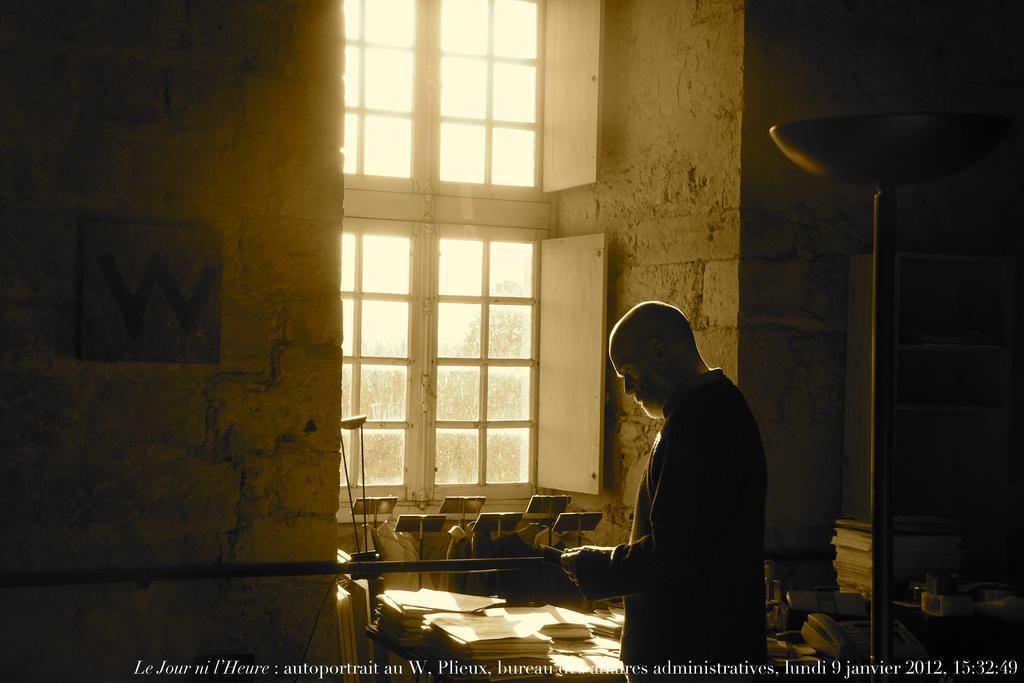Could you give a brief overview of what you see in this image? In this picture I can observe a person standing in front of a table on which I can observe some papers. There is some text on the bottom of the picture. On the right side there are some books placed on the desk. On the left side I can observe a photo frame fixed to the wall. There are windows. In the background there are trees and a sky. 